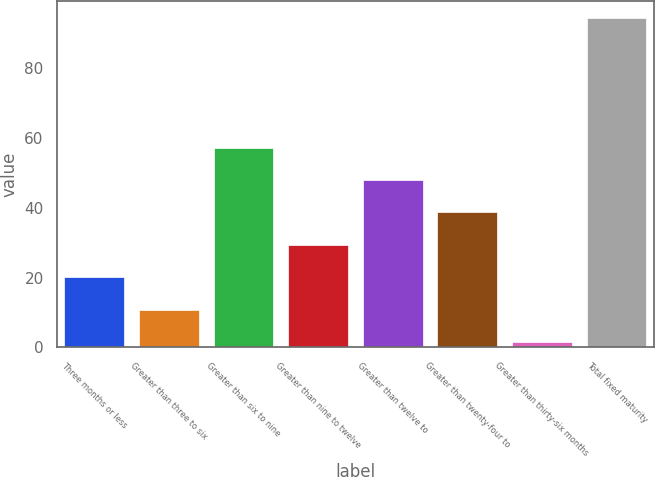Convert chart. <chart><loc_0><loc_0><loc_500><loc_500><bar_chart><fcel>Three months or less<fcel>Greater than three to six<fcel>Greater than six to nine<fcel>Greater than nine to twelve<fcel>Greater than twelve to<fcel>Greater than twenty-four to<fcel>Greater than thirty-six months<fcel>Total fixed maturity<nl><fcel>20.08<fcel>10.79<fcel>57.24<fcel>29.37<fcel>47.95<fcel>38.66<fcel>1.5<fcel>94.4<nl></chart> 